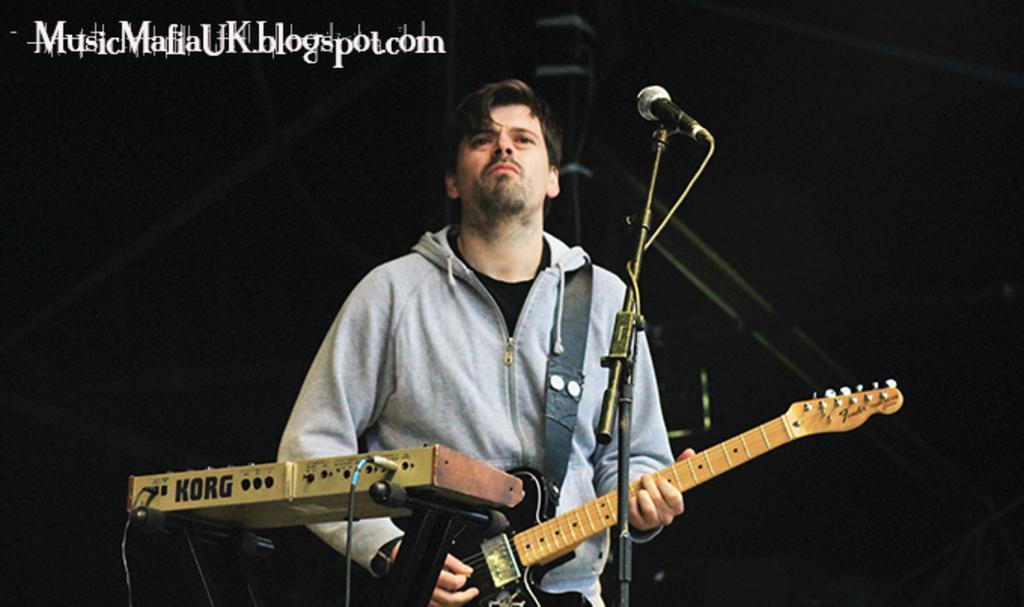Could you give a brief overview of what you see in this image? In this image there is a there is a man standing on the stage and playing guitar in front of a microphone stand, beside that there is a music player. 